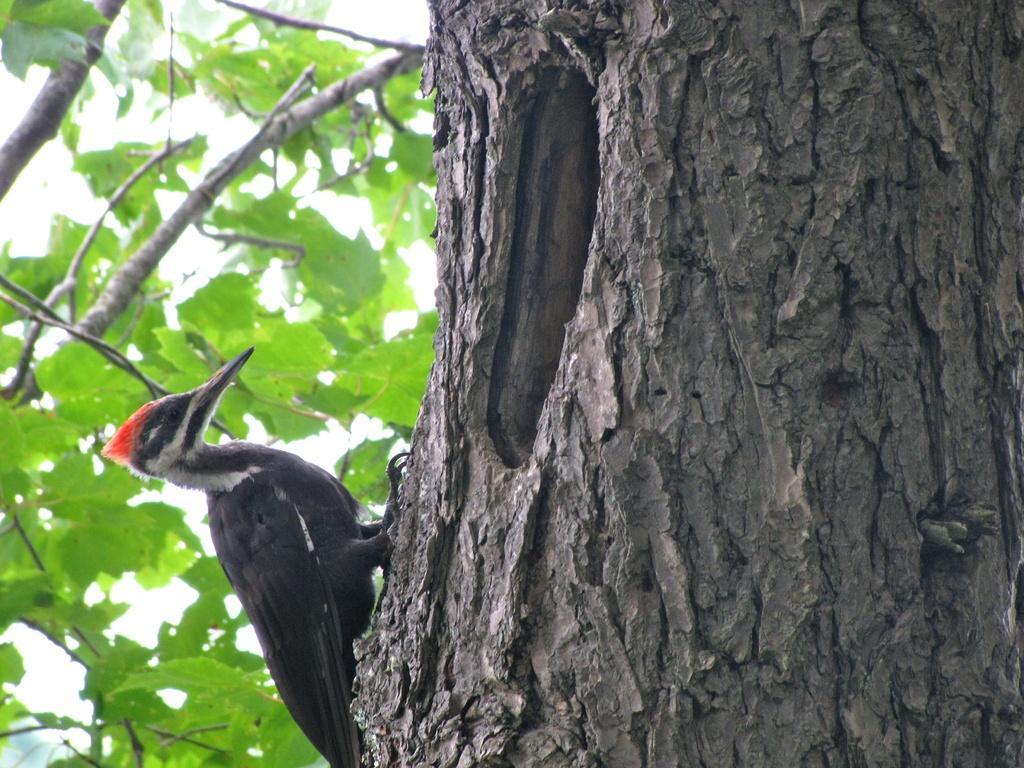In one or two sentences, can you explain what this image depicts? There is a woodpecker on a tree. 